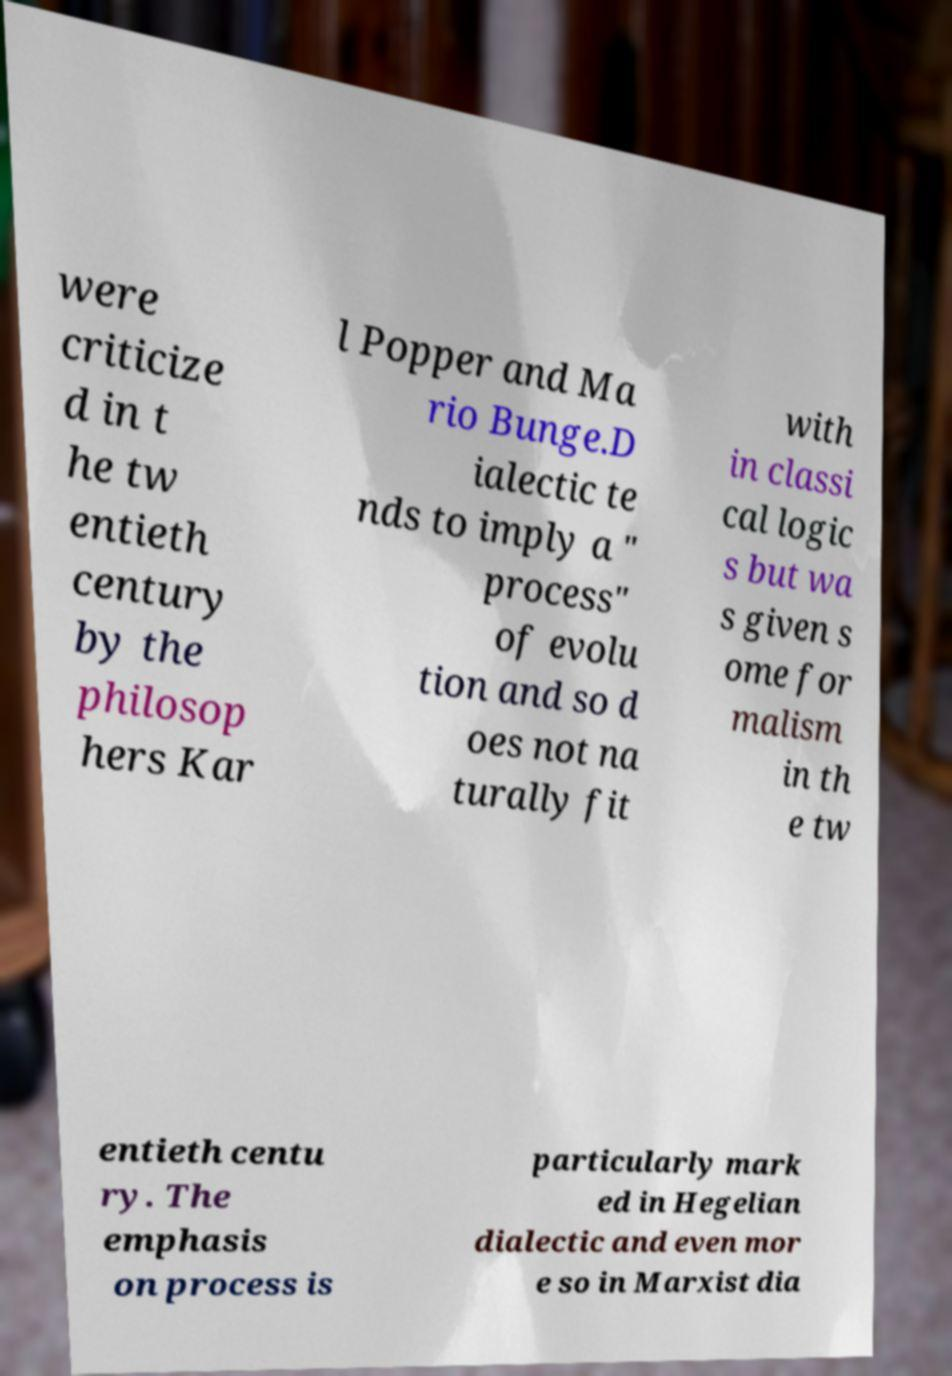What messages or text are displayed in this image? I need them in a readable, typed format. were criticize d in t he tw entieth century by the philosop hers Kar l Popper and Ma rio Bunge.D ialectic te nds to imply a " process" of evolu tion and so d oes not na turally fit with in classi cal logic s but wa s given s ome for malism in th e tw entieth centu ry. The emphasis on process is particularly mark ed in Hegelian dialectic and even mor e so in Marxist dia 